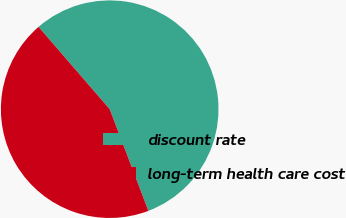Convert chart. <chart><loc_0><loc_0><loc_500><loc_500><pie_chart><fcel>discount rate<fcel>long-term health care cost<nl><fcel>55.56%<fcel>44.44%<nl></chart> 